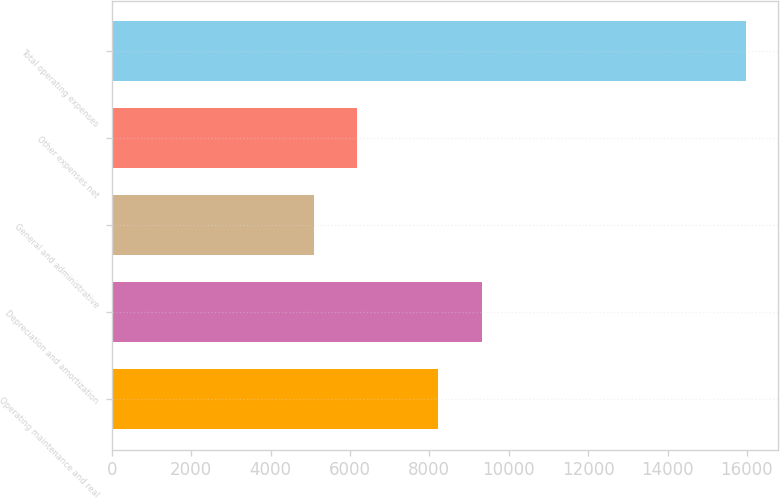<chart> <loc_0><loc_0><loc_500><loc_500><bar_chart><fcel>Operating maintenance and real<fcel>Depreciation and amortization<fcel>General and administrative<fcel>Other expenses net<fcel>Total operating expenses<nl><fcel>8229<fcel>9318.3<fcel>5085<fcel>6174.3<fcel>15978<nl></chart> 